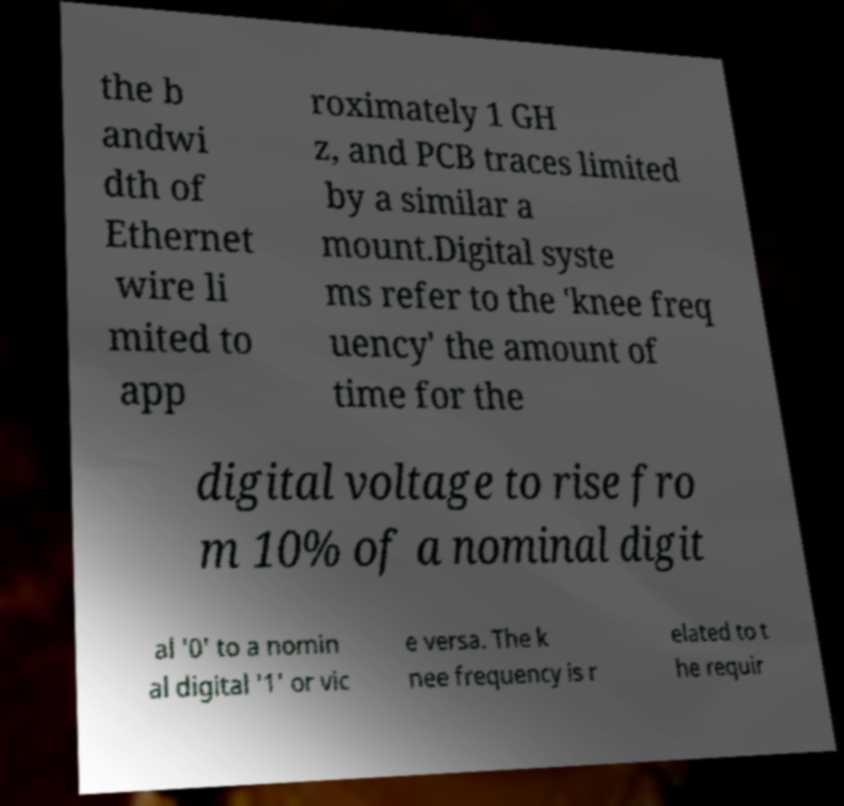Could you assist in decoding the text presented in this image and type it out clearly? the b andwi dth of Ethernet wire li mited to app roximately 1 GH z, and PCB traces limited by a similar a mount.Digital syste ms refer to the 'knee freq uency' the amount of time for the digital voltage to rise fro m 10% of a nominal digit al '0' to a nomin al digital '1' or vic e versa. The k nee frequency is r elated to t he requir 